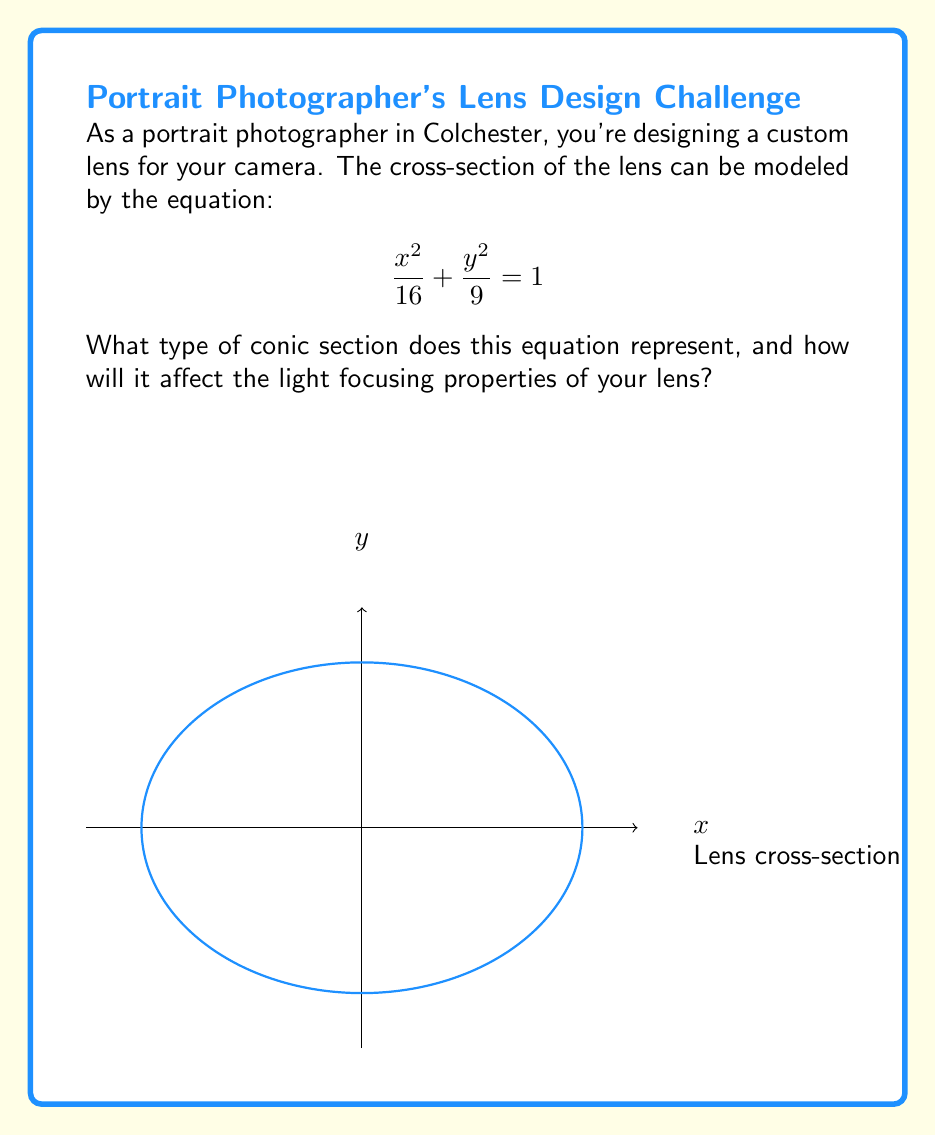Solve this math problem. To determine the shape of the lens cross-section, we need to analyze the given equation:

$$\frac{x^2}{16} + \frac{y^2}{9} = 1$$

1. Recognize the standard form of a conic section:
   $$\frac{x^2}{a^2} + \frac{y^2}{b^2} = 1$$

2. In this case, $a^2 = 16$ and $b^2 = 9$, so $a = 4$ and $b = 3$.

3. Since both terms are positive and the right-hand side is 1, this equation represents an ellipse.

4. The semi-major axis is the larger value between $a$ and $b$, which is 4 (horizontal).
   The semi-minor axis is the smaller value, which is 3 (vertical).

5. This elliptical shape will affect the light focusing properties of the lens:
   - It will converge light rays to a focal point.
   - The lens will have different focusing power in horizontal and vertical directions (astigmatism).
   - This asymmetry can be useful for correcting certain optical aberrations or creating artistic effects in portrait photography.
Answer: Ellipse; converges light asymmetrically 